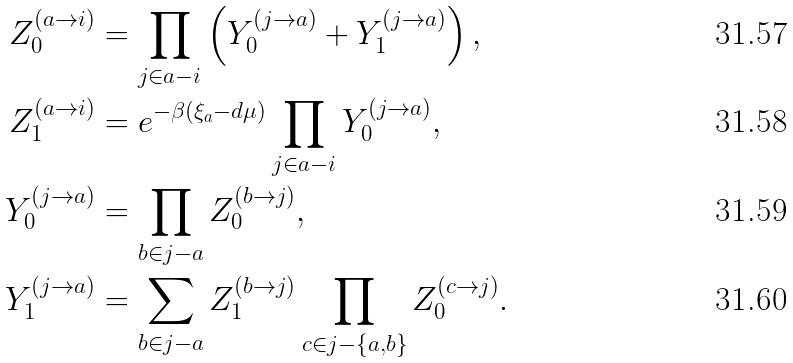<formula> <loc_0><loc_0><loc_500><loc_500>Z ^ { ( a \to i ) } _ { 0 } & = \prod _ { j \in a - i } \left ( Y ^ { ( j \to a ) } _ { 0 } + Y ^ { ( j \to a ) } _ { 1 } \right ) , \\ Z ^ { ( a \to i ) } _ { 1 } & = e ^ { - \beta ( \xi _ { a } - d \mu ) } \prod _ { j \in a - i } Y ^ { ( j \to a ) } _ { 0 } , \\ Y ^ { ( j \to a ) } _ { 0 } & = \prod _ { b \in j - a } Z ^ { ( b \to j ) } _ { 0 } , \\ Y ^ { ( j \to a ) } _ { 1 } & = \sum _ { b \in j - a } Z ^ { ( b \to j ) } _ { 1 } \prod _ { c \in j - \{ a , b \} } Z ^ { ( c \to j ) } _ { 0 } .</formula> 